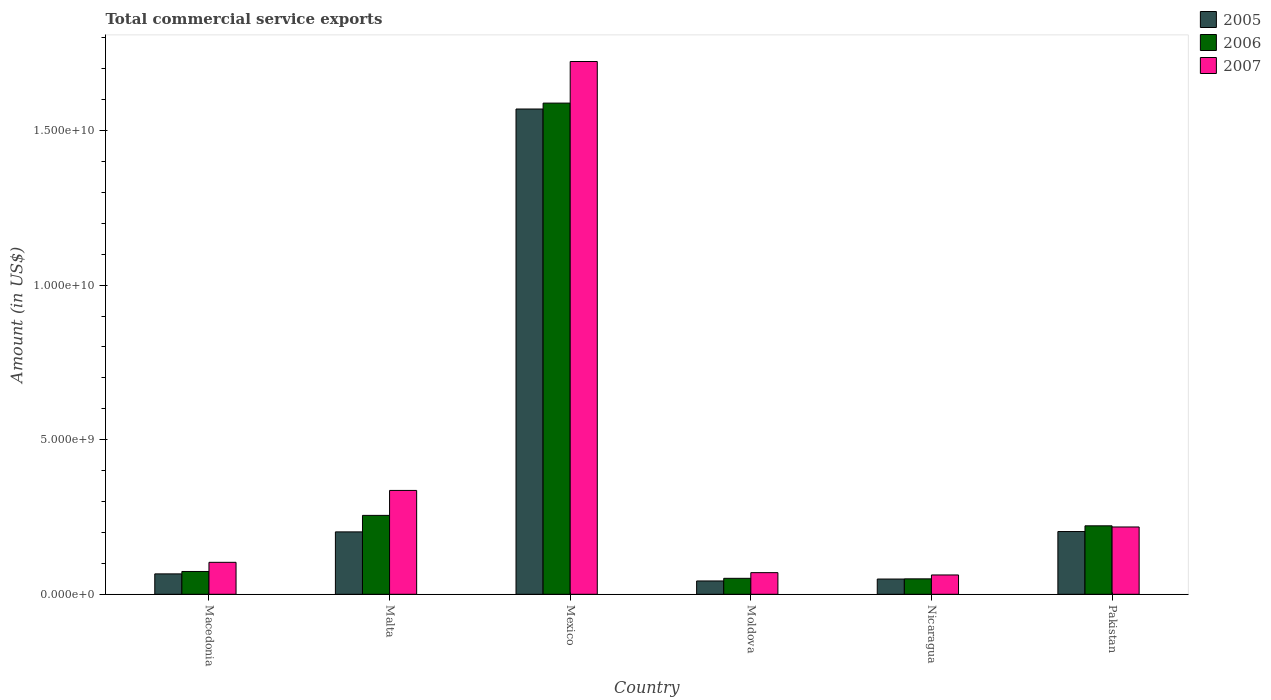How many bars are there on the 4th tick from the left?
Your response must be concise. 3. How many bars are there on the 1st tick from the right?
Offer a terse response. 3. What is the label of the 2nd group of bars from the left?
Give a very brief answer. Malta. In how many cases, is the number of bars for a given country not equal to the number of legend labels?
Offer a terse response. 0. What is the total commercial service exports in 2005 in Macedonia?
Offer a terse response. 6.60e+08. Across all countries, what is the maximum total commercial service exports in 2006?
Give a very brief answer. 1.59e+1. Across all countries, what is the minimum total commercial service exports in 2005?
Ensure brevity in your answer.  4.31e+08. In which country was the total commercial service exports in 2007 maximum?
Provide a short and direct response. Mexico. In which country was the total commercial service exports in 2007 minimum?
Make the answer very short. Nicaragua. What is the total total commercial service exports in 2005 in the graph?
Provide a short and direct response. 2.13e+1. What is the difference between the total commercial service exports in 2007 in Malta and that in Moldova?
Your response must be concise. 2.66e+09. What is the difference between the total commercial service exports in 2006 in Mexico and the total commercial service exports in 2007 in Nicaragua?
Offer a terse response. 1.53e+1. What is the average total commercial service exports in 2005 per country?
Your answer should be compact. 3.56e+09. What is the difference between the total commercial service exports of/in 2006 and total commercial service exports of/in 2007 in Pakistan?
Make the answer very short. 3.73e+07. What is the ratio of the total commercial service exports in 2006 in Malta to that in Pakistan?
Ensure brevity in your answer.  1.15. Is the total commercial service exports in 2006 in Nicaragua less than that in Pakistan?
Ensure brevity in your answer.  Yes. Is the difference between the total commercial service exports in 2006 in Moldova and Nicaragua greater than the difference between the total commercial service exports in 2007 in Moldova and Nicaragua?
Give a very brief answer. No. What is the difference between the highest and the second highest total commercial service exports in 2007?
Your answer should be very brief. -1.51e+1. What is the difference between the highest and the lowest total commercial service exports in 2006?
Your answer should be very brief. 1.54e+1. In how many countries, is the total commercial service exports in 2007 greater than the average total commercial service exports in 2007 taken over all countries?
Ensure brevity in your answer.  1. Is the sum of the total commercial service exports in 2007 in Malta and Pakistan greater than the maximum total commercial service exports in 2005 across all countries?
Your answer should be very brief. No. Is it the case that in every country, the sum of the total commercial service exports in 2006 and total commercial service exports in 2005 is greater than the total commercial service exports in 2007?
Your response must be concise. Yes. Are all the bars in the graph horizontal?
Your answer should be very brief. No. How many countries are there in the graph?
Provide a succinct answer. 6. Are the values on the major ticks of Y-axis written in scientific E-notation?
Provide a succinct answer. Yes. How many legend labels are there?
Keep it short and to the point. 3. How are the legend labels stacked?
Your answer should be compact. Vertical. What is the title of the graph?
Provide a succinct answer. Total commercial service exports. What is the Amount (in US$) in 2005 in Macedonia?
Your answer should be very brief. 6.60e+08. What is the Amount (in US$) of 2006 in Macedonia?
Your response must be concise. 7.38e+08. What is the Amount (in US$) of 2007 in Macedonia?
Offer a very short reply. 1.03e+09. What is the Amount (in US$) of 2005 in Malta?
Provide a succinct answer. 2.02e+09. What is the Amount (in US$) in 2006 in Malta?
Your response must be concise. 2.55e+09. What is the Amount (in US$) in 2007 in Malta?
Keep it short and to the point. 3.36e+09. What is the Amount (in US$) of 2005 in Mexico?
Make the answer very short. 1.57e+1. What is the Amount (in US$) in 2006 in Mexico?
Provide a succinct answer. 1.59e+1. What is the Amount (in US$) of 2007 in Mexico?
Ensure brevity in your answer.  1.72e+1. What is the Amount (in US$) in 2005 in Moldova?
Your answer should be compact. 4.31e+08. What is the Amount (in US$) in 2006 in Moldova?
Provide a succinct answer. 5.17e+08. What is the Amount (in US$) of 2007 in Moldova?
Offer a terse response. 7.00e+08. What is the Amount (in US$) of 2005 in Nicaragua?
Provide a short and direct response. 4.93e+08. What is the Amount (in US$) of 2006 in Nicaragua?
Ensure brevity in your answer.  5.00e+08. What is the Amount (in US$) of 2007 in Nicaragua?
Your response must be concise. 6.25e+08. What is the Amount (in US$) in 2005 in Pakistan?
Offer a very short reply. 2.03e+09. What is the Amount (in US$) in 2006 in Pakistan?
Offer a very short reply. 2.22e+09. What is the Amount (in US$) in 2007 in Pakistan?
Keep it short and to the point. 2.18e+09. Across all countries, what is the maximum Amount (in US$) in 2005?
Make the answer very short. 1.57e+1. Across all countries, what is the maximum Amount (in US$) of 2006?
Provide a short and direct response. 1.59e+1. Across all countries, what is the maximum Amount (in US$) in 2007?
Keep it short and to the point. 1.72e+1. Across all countries, what is the minimum Amount (in US$) of 2005?
Your answer should be compact. 4.31e+08. Across all countries, what is the minimum Amount (in US$) of 2006?
Your answer should be very brief. 5.00e+08. Across all countries, what is the minimum Amount (in US$) of 2007?
Provide a short and direct response. 6.25e+08. What is the total Amount (in US$) in 2005 in the graph?
Your response must be concise. 2.13e+1. What is the total Amount (in US$) in 2006 in the graph?
Ensure brevity in your answer.  2.24e+1. What is the total Amount (in US$) of 2007 in the graph?
Your answer should be very brief. 2.51e+1. What is the difference between the Amount (in US$) in 2005 in Macedonia and that in Malta?
Keep it short and to the point. -1.36e+09. What is the difference between the Amount (in US$) of 2006 in Macedonia and that in Malta?
Provide a succinct answer. -1.81e+09. What is the difference between the Amount (in US$) of 2007 in Macedonia and that in Malta?
Give a very brief answer. -2.33e+09. What is the difference between the Amount (in US$) of 2005 in Macedonia and that in Mexico?
Offer a terse response. -1.50e+1. What is the difference between the Amount (in US$) of 2006 in Macedonia and that in Mexico?
Provide a short and direct response. -1.52e+1. What is the difference between the Amount (in US$) in 2007 in Macedonia and that in Mexico?
Give a very brief answer. -1.62e+1. What is the difference between the Amount (in US$) of 2005 in Macedonia and that in Moldova?
Your answer should be compact. 2.29e+08. What is the difference between the Amount (in US$) of 2006 in Macedonia and that in Moldova?
Keep it short and to the point. 2.21e+08. What is the difference between the Amount (in US$) in 2007 in Macedonia and that in Moldova?
Ensure brevity in your answer.  3.34e+08. What is the difference between the Amount (in US$) in 2005 in Macedonia and that in Nicaragua?
Ensure brevity in your answer.  1.67e+08. What is the difference between the Amount (in US$) of 2006 in Macedonia and that in Nicaragua?
Keep it short and to the point. 2.38e+08. What is the difference between the Amount (in US$) in 2007 in Macedonia and that in Nicaragua?
Offer a terse response. 4.09e+08. What is the difference between the Amount (in US$) in 2005 in Macedonia and that in Pakistan?
Your answer should be very brief. -1.37e+09. What is the difference between the Amount (in US$) of 2006 in Macedonia and that in Pakistan?
Provide a succinct answer. -1.48e+09. What is the difference between the Amount (in US$) of 2007 in Macedonia and that in Pakistan?
Make the answer very short. -1.14e+09. What is the difference between the Amount (in US$) of 2005 in Malta and that in Mexico?
Provide a succinct answer. -1.37e+1. What is the difference between the Amount (in US$) of 2006 in Malta and that in Mexico?
Your response must be concise. -1.33e+1. What is the difference between the Amount (in US$) in 2007 in Malta and that in Mexico?
Offer a very short reply. -1.39e+1. What is the difference between the Amount (in US$) in 2005 in Malta and that in Moldova?
Keep it short and to the point. 1.59e+09. What is the difference between the Amount (in US$) in 2006 in Malta and that in Moldova?
Keep it short and to the point. 2.04e+09. What is the difference between the Amount (in US$) of 2007 in Malta and that in Moldova?
Your answer should be very brief. 2.66e+09. What is the difference between the Amount (in US$) of 2005 in Malta and that in Nicaragua?
Provide a succinct answer. 1.53e+09. What is the difference between the Amount (in US$) of 2006 in Malta and that in Nicaragua?
Make the answer very short. 2.05e+09. What is the difference between the Amount (in US$) of 2007 in Malta and that in Nicaragua?
Ensure brevity in your answer.  2.73e+09. What is the difference between the Amount (in US$) of 2005 in Malta and that in Pakistan?
Offer a terse response. -1.15e+07. What is the difference between the Amount (in US$) of 2006 in Malta and that in Pakistan?
Provide a short and direct response. 3.38e+08. What is the difference between the Amount (in US$) of 2007 in Malta and that in Pakistan?
Provide a short and direct response. 1.18e+09. What is the difference between the Amount (in US$) in 2005 in Mexico and that in Moldova?
Provide a short and direct response. 1.53e+1. What is the difference between the Amount (in US$) of 2006 in Mexico and that in Moldova?
Your response must be concise. 1.54e+1. What is the difference between the Amount (in US$) in 2007 in Mexico and that in Moldova?
Ensure brevity in your answer.  1.65e+1. What is the difference between the Amount (in US$) in 2005 in Mexico and that in Nicaragua?
Offer a very short reply. 1.52e+1. What is the difference between the Amount (in US$) in 2006 in Mexico and that in Nicaragua?
Make the answer very short. 1.54e+1. What is the difference between the Amount (in US$) in 2007 in Mexico and that in Nicaragua?
Your response must be concise. 1.66e+1. What is the difference between the Amount (in US$) of 2005 in Mexico and that in Pakistan?
Your response must be concise. 1.37e+1. What is the difference between the Amount (in US$) in 2006 in Mexico and that in Pakistan?
Give a very brief answer. 1.37e+1. What is the difference between the Amount (in US$) of 2007 in Mexico and that in Pakistan?
Keep it short and to the point. 1.51e+1. What is the difference between the Amount (in US$) of 2005 in Moldova and that in Nicaragua?
Make the answer very short. -6.21e+07. What is the difference between the Amount (in US$) of 2006 in Moldova and that in Nicaragua?
Make the answer very short. 1.72e+07. What is the difference between the Amount (in US$) in 2007 in Moldova and that in Nicaragua?
Offer a very short reply. 7.50e+07. What is the difference between the Amount (in US$) in 2005 in Moldova and that in Pakistan?
Provide a short and direct response. -1.60e+09. What is the difference between the Amount (in US$) of 2006 in Moldova and that in Pakistan?
Give a very brief answer. -1.70e+09. What is the difference between the Amount (in US$) in 2007 in Moldova and that in Pakistan?
Your answer should be compact. -1.48e+09. What is the difference between the Amount (in US$) in 2005 in Nicaragua and that in Pakistan?
Make the answer very short. -1.54e+09. What is the difference between the Amount (in US$) in 2006 in Nicaragua and that in Pakistan?
Provide a succinct answer. -1.72e+09. What is the difference between the Amount (in US$) in 2007 in Nicaragua and that in Pakistan?
Provide a short and direct response. -1.55e+09. What is the difference between the Amount (in US$) in 2005 in Macedonia and the Amount (in US$) in 2006 in Malta?
Make the answer very short. -1.89e+09. What is the difference between the Amount (in US$) of 2005 in Macedonia and the Amount (in US$) of 2007 in Malta?
Provide a short and direct response. -2.70e+09. What is the difference between the Amount (in US$) of 2006 in Macedonia and the Amount (in US$) of 2007 in Malta?
Your answer should be compact. -2.62e+09. What is the difference between the Amount (in US$) in 2005 in Macedonia and the Amount (in US$) in 2006 in Mexico?
Keep it short and to the point. -1.52e+1. What is the difference between the Amount (in US$) in 2005 in Macedonia and the Amount (in US$) in 2007 in Mexico?
Offer a very short reply. -1.66e+1. What is the difference between the Amount (in US$) of 2006 in Macedonia and the Amount (in US$) of 2007 in Mexico?
Your answer should be compact. -1.65e+1. What is the difference between the Amount (in US$) in 2005 in Macedonia and the Amount (in US$) in 2006 in Moldova?
Your response must be concise. 1.44e+08. What is the difference between the Amount (in US$) of 2005 in Macedonia and the Amount (in US$) of 2007 in Moldova?
Ensure brevity in your answer.  -4.00e+07. What is the difference between the Amount (in US$) in 2006 in Macedonia and the Amount (in US$) in 2007 in Moldova?
Your answer should be compact. 3.76e+07. What is the difference between the Amount (in US$) in 2005 in Macedonia and the Amount (in US$) in 2006 in Nicaragua?
Your answer should be compact. 1.61e+08. What is the difference between the Amount (in US$) of 2005 in Macedonia and the Amount (in US$) of 2007 in Nicaragua?
Make the answer very short. 3.50e+07. What is the difference between the Amount (in US$) in 2006 in Macedonia and the Amount (in US$) in 2007 in Nicaragua?
Make the answer very short. 1.13e+08. What is the difference between the Amount (in US$) of 2005 in Macedonia and the Amount (in US$) of 2006 in Pakistan?
Keep it short and to the point. -1.55e+09. What is the difference between the Amount (in US$) of 2005 in Macedonia and the Amount (in US$) of 2007 in Pakistan?
Provide a succinct answer. -1.52e+09. What is the difference between the Amount (in US$) in 2006 in Macedonia and the Amount (in US$) in 2007 in Pakistan?
Your answer should be very brief. -1.44e+09. What is the difference between the Amount (in US$) of 2005 in Malta and the Amount (in US$) of 2006 in Mexico?
Give a very brief answer. -1.39e+1. What is the difference between the Amount (in US$) of 2005 in Malta and the Amount (in US$) of 2007 in Mexico?
Give a very brief answer. -1.52e+1. What is the difference between the Amount (in US$) of 2006 in Malta and the Amount (in US$) of 2007 in Mexico?
Ensure brevity in your answer.  -1.47e+1. What is the difference between the Amount (in US$) of 2005 in Malta and the Amount (in US$) of 2006 in Moldova?
Make the answer very short. 1.50e+09. What is the difference between the Amount (in US$) of 2005 in Malta and the Amount (in US$) of 2007 in Moldova?
Your answer should be compact. 1.32e+09. What is the difference between the Amount (in US$) of 2006 in Malta and the Amount (in US$) of 2007 in Moldova?
Your answer should be very brief. 1.85e+09. What is the difference between the Amount (in US$) of 2005 in Malta and the Amount (in US$) of 2006 in Nicaragua?
Offer a very short reply. 1.52e+09. What is the difference between the Amount (in US$) of 2005 in Malta and the Amount (in US$) of 2007 in Nicaragua?
Your answer should be very brief. 1.39e+09. What is the difference between the Amount (in US$) in 2006 in Malta and the Amount (in US$) in 2007 in Nicaragua?
Provide a short and direct response. 1.93e+09. What is the difference between the Amount (in US$) in 2005 in Malta and the Amount (in US$) in 2006 in Pakistan?
Give a very brief answer. -1.96e+08. What is the difference between the Amount (in US$) of 2005 in Malta and the Amount (in US$) of 2007 in Pakistan?
Your response must be concise. -1.59e+08. What is the difference between the Amount (in US$) in 2006 in Malta and the Amount (in US$) in 2007 in Pakistan?
Make the answer very short. 3.75e+08. What is the difference between the Amount (in US$) of 2005 in Mexico and the Amount (in US$) of 2006 in Moldova?
Your answer should be very brief. 1.52e+1. What is the difference between the Amount (in US$) in 2005 in Mexico and the Amount (in US$) in 2007 in Moldova?
Offer a very short reply. 1.50e+1. What is the difference between the Amount (in US$) of 2006 in Mexico and the Amount (in US$) of 2007 in Moldova?
Give a very brief answer. 1.52e+1. What is the difference between the Amount (in US$) in 2005 in Mexico and the Amount (in US$) in 2006 in Nicaragua?
Your answer should be very brief. 1.52e+1. What is the difference between the Amount (in US$) in 2005 in Mexico and the Amount (in US$) in 2007 in Nicaragua?
Your answer should be very brief. 1.51e+1. What is the difference between the Amount (in US$) of 2006 in Mexico and the Amount (in US$) of 2007 in Nicaragua?
Give a very brief answer. 1.53e+1. What is the difference between the Amount (in US$) in 2005 in Mexico and the Amount (in US$) in 2006 in Pakistan?
Offer a terse response. 1.35e+1. What is the difference between the Amount (in US$) of 2005 in Mexico and the Amount (in US$) of 2007 in Pakistan?
Ensure brevity in your answer.  1.35e+1. What is the difference between the Amount (in US$) of 2006 in Mexico and the Amount (in US$) of 2007 in Pakistan?
Your answer should be very brief. 1.37e+1. What is the difference between the Amount (in US$) of 2005 in Moldova and the Amount (in US$) of 2006 in Nicaragua?
Keep it short and to the point. -6.83e+07. What is the difference between the Amount (in US$) of 2005 in Moldova and the Amount (in US$) of 2007 in Nicaragua?
Make the answer very short. -1.94e+08. What is the difference between the Amount (in US$) of 2006 in Moldova and the Amount (in US$) of 2007 in Nicaragua?
Offer a terse response. -1.09e+08. What is the difference between the Amount (in US$) in 2005 in Moldova and the Amount (in US$) in 2006 in Pakistan?
Ensure brevity in your answer.  -1.78e+09. What is the difference between the Amount (in US$) in 2005 in Moldova and the Amount (in US$) in 2007 in Pakistan?
Your response must be concise. -1.75e+09. What is the difference between the Amount (in US$) in 2006 in Moldova and the Amount (in US$) in 2007 in Pakistan?
Make the answer very short. -1.66e+09. What is the difference between the Amount (in US$) of 2005 in Nicaragua and the Amount (in US$) of 2006 in Pakistan?
Offer a terse response. -1.72e+09. What is the difference between the Amount (in US$) of 2005 in Nicaragua and the Amount (in US$) of 2007 in Pakistan?
Provide a succinct answer. -1.68e+09. What is the difference between the Amount (in US$) in 2006 in Nicaragua and the Amount (in US$) in 2007 in Pakistan?
Your response must be concise. -1.68e+09. What is the average Amount (in US$) of 2005 per country?
Your answer should be very brief. 3.56e+09. What is the average Amount (in US$) of 2006 per country?
Give a very brief answer. 3.74e+09. What is the average Amount (in US$) in 2007 per country?
Offer a very short reply. 4.19e+09. What is the difference between the Amount (in US$) in 2005 and Amount (in US$) in 2006 in Macedonia?
Give a very brief answer. -7.75e+07. What is the difference between the Amount (in US$) of 2005 and Amount (in US$) of 2007 in Macedonia?
Provide a short and direct response. -3.74e+08. What is the difference between the Amount (in US$) of 2006 and Amount (in US$) of 2007 in Macedonia?
Your response must be concise. -2.96e+08. What is the difference between the Amount (in US$) of 2005 and Amount (in US$) of 2006 in Malta?
Offer a very short reply. -5.34e+08. What is the difference between the Amount (in US$) in 2005 and Amount (in US$) in 2007 in Malta?
Offer a very short reply. -1.34e+09. What is the difference between the Amount (in US$) of 2006 and Amount (in US$) of 2007 in Malta?
Your response must be concise. -8.07e+08. What is the difference between the Amount (in US$) of 2005 and Amount (in US$) of 2006 in Mexico?
Keep it short and to the point. -1.91e+08. What is the difference between the Amount (in US$) of 2005 and Amount (in US$) of 2007 in Mexico?
Provide a succinct answer. -1.54e+09. What is the difference between the Amount (in US$) in 2006 and Amount (in US$) in 2007 in Mexico?
Ensure brevity in your answer.  -1.35e+09. What is the difference between the Amount (in US$) in 2005 and Amount (in US$) in 2006 in Moldova?
Your answer should be very brief. -8.55e+07. What is the difference between the Amount (in US$) of 2005 and Amount (in US$) of 2007 in Moldova?
Give a very brief answer. -2.69e+08. What is the difference between the Amount (in US$) of 2006 and Amount (in US$) of 2007 in Moldova?
Offer a terse response. -1.84e+08. What is the difference between the Amount (in US$) of 2005 and Amount (in US$) of 2006 in Nicaragua?
Ensure brevity in your answer.  -6.20e+06. What is the difference between the Amount (in US$) in 2005 and Amount (in US$) in 2007 in Nicaragua?
Ensure brevity in your answer.  -1.32e+08. What is the difference between the Amount (in US$) in 2006 and Amount (in US$) in 2007 in Nicaragua?
Provide a succinct answer. -1.26e+08. What is the difference between the Amount (in US$) in 2005 and Amount (in US$) in 2006 in Pakistan?
Provide a short and direct response. -1.85e+08. What is the difference between the Amount (in US$) of 2005 and Amount (in US$) of 2007 in Pakistan?
Keep it short and to the point. -1.48e+08. What is the difference between the Amount (in US$) in 2006 and Amount (in US$) in 2007 in Pakistan?
Offer a terse response. 3.73e+07. What is the ratio of the Amount (in US$) of 2005 in Macedonia to that in Malta?
Ensure brevity in your answer.  0.33. What is the ratio of the Amount (in US$) in 2006 in Macedonia to that in Malta?
Keep it short and to the point. 0.29. What is the ratio of the Amount (in US$) of 2007 in Macedonia to that in Malta?
Your answer should be very brief. 0.31. What is the ratio of the Amount (in US$) of 2005 in Macedonia to that in Mexico?
Your response must be concise. 0.04. What is the ratio of the Amount (in US$) in 2006 in Macedonia to that in Mexico?
Offer a terse response. 0.05. What is the ratio of the Amount (in US$) of 2007 in Macedonia to that in Mexico?
Keep it short and to the point. 0.06. What is the ratio of the Amount (in US$) of 2005 in Macedonia to that in Moldova?
Provide a succinct answer. 1.53. What is the ratio of the Amount (in US$) in 2006 in Macedonia to that in Moldova?
Ensure brevity in your answer.  1.43. What is the ratio of the Amount (in US$) of 2007 in Macedonia to that in Moldova?
Offer a very short reply. 1.48. What is the ratio of the Amount (in US$) in 2005 in Macedonia to that in Nicaragua?
Your response must be concise. 1.34. What is the ratio of the Amount (in US$) in 2006 in Macedonia to that in Nicaragua?
Keep it short and to the point. 1.48. What is the ratio of the Amount (in US$) in 2007 in Macedonia to that in Nicaragua?
Keep it short and to the point. 1.65. What is the ratio of the Amount (in US$) of 2005 in Macedonia to that in Pakistan?
Offer a very short reply. 0.33. What is the ratio of the Amount (in US$) in 2006 in Macedonia to that in Pakistan?
Provide a succinct answer. 0.33. What is the ratio of the Amount (in US$) in 2007 in Macedonia to that in Pakistan?
Your answer should be compact. 0.47. What is the ratio of the Amount (in US$) in 2005 in Malta to that in Mexico?
Your answer should be very brief. 0.13. What is the ratio of the Amount (in US$) in 2006 in Malta to that in Mexico?
Your response must be concise. 0.16. What is the ratio of the Amount (in US$) of 2007 in Malta to that in Mexico?
Make the answer very short. 0.2. What is the ratio of the Amount (in US$) in 2005 in Malta to that in Moldova?
Offer a very short reply. 4.68. What is the ratio of the Amount (in US$) of 2006 in Malta to that in Moldova?
Make the answer very short. 4.94. What is the ratio of the Amount (in US$) in 2007 in Malta to that in Moldova?
Provide a short and direct response. 4.8. What is the ratio of the Amount (in US$) of 2005 in Malta to that in Nicaragua?
Offer a terse response. 4.09. What is the ratio of the Amount (in US$) in 2006 in Malta to that in Nicaragua?
Offer a terse response. 5.11. What is the ratio of the Amount (in US$) in 2007 in Malta to that in Nicaragua?
Provide a succinct answer. 5.37. What is the ratio of the Amount (in US$) in 2006 in Malta to that in Pakistan?
Make the answer very short. 1.15. What is the ratio of the Amount (in US$) in 2007 in Malta to that in Pakistan?
Provide a succinct answer. 1.54. What is the ratio of the Amount (in US$) in 2005 in Mexico to that in Moldova?
Ensure brevity in your answer.  36.39. What is the ratio of the Amount (in US$) in 2006 in Mexico to that in Moldova?
Offer a terse response. 30.74. What is the ratio of the Amount (in US$) in 2007 in Mexico to that in Moldova?
Keep it short and to the point. 24.61. What is the ratio of the Amount (in US$) in 2005 in Mexico to that in Nicaragua?
Offer a very short reply. 31.81. What is the ratio of the Amount (in US$) in 2006 in Mexico to that in Nicaragua?
Offer a terse response. 31.8. What is the ratio of the Amount (in US$) in 2007 in Mexico to that in Nicaragua?
Keep it short and to the point. 27.56. What is the ratio of the Amount (in US$) in 2005 in Mexico to that in Pakistan?
Give a very brief answer. 7.73. What is the ratio of the Amount (in US$) in 2006 in Mexico to that in Pakistan?
Give a very brief answer. 7.17. What is the ratio of the Amount (in US$) of 2007 in Mexico to that in Pakistan?
Keep it short and to the point. 7.91. What is the ratio of the Amount (in US$) of 2005 in Moldova to that in Nicaragua?
Provide a short and direct response. 0.87. What is the ratio of the Amount (in US$) of 2006 in Moldova to that in Nicaragua?
Offer a very short reply. 1.03. What is the ratio of the Amount (in US$) in 2007 in Moldova to that in Nicaragua?
Provide a succinct answer. 1.12. What is the ratio of the Amount (in US$) of 2005 in Moldova to that in Pakistan?
Your answer should be very brief. 0.21. What is the ratio of the Amount (in US$) in 2006 in Moldova to that in Pakistan?
Your response must be concise. 0.23. What is the ratio of the Amount (in US$) of 2007 in Moldova to that in Pakistan?
Offer a very short reply. 0.32. What is the ratio of the Amount (in US$) in 2005 in Nicaragua to that in Pakistan?
Keep it short and to the point. 0.24. What is the ratio of the Amount (in US$) of 2006 in Nicaragua to that in Pakistan?
Offer a very short reply. 0.23. What is the ratio of the Amount (in US$) in 2007 in Nicaragua to that in Pakistan?
Your answer should be compact. 0.29. What is the difference between the highest and the second highest Amount (in US$) of 2005?
Ensure brevity in your answer.  1.37e+1. What is the difference between the highest and the second highest Amount (in US$) of 2006?
Your answer should be compact. 1.33e+1. What is the difference between the highest and the second highest Amount (in US$) of 2007?
Provide a succinct answer. 1.39e+1. What is the difference between the highest and the lowest Amount (in US$) in 2005?
Your answer should be very brief. 1.53e+1. What is the difference between the highest and the lowest Amount (in US$) in 2006?
Ensure brevity in your answer.  1.54e+1. What is the difference between the highest and the lowest Amount (in US$) of 2007?
Make the answer very short. 1.66e+1. 